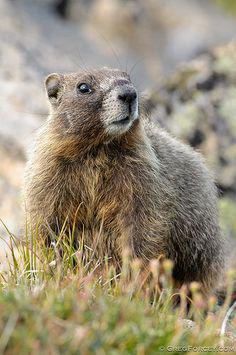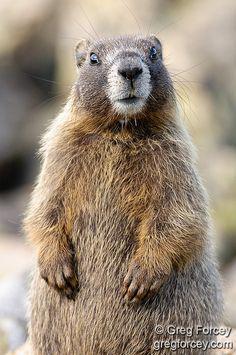The first image is the image on the left, the second image is the image on the right. Considering the images on both sides, is "At least one rodent-type animal is standing upright." valid? Answer yes or no. Yes. 